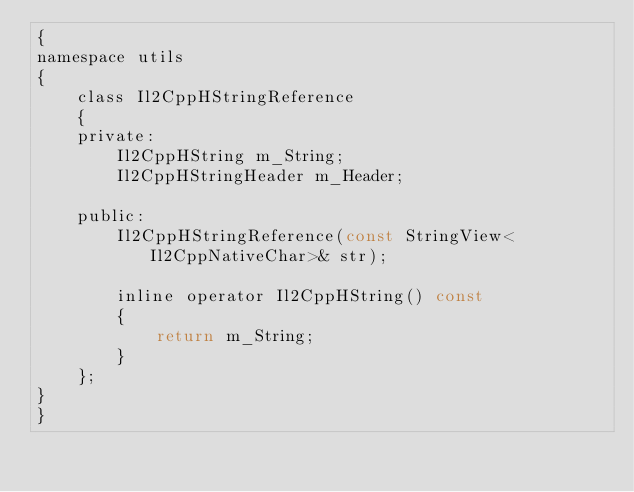Convert code to text. <code><loc_0><loc_0><loc_500><loc_500><_C_>{
namespace utils
{
    class Il2CppHStringReference
    {
    private:
        Il2CppHString m_String;
        Il2CppHStringHeader m_Header;

    public:
        Il2CppHStringReference(const StringView<Il2CppNativeChar>& str);

        inline operator Il2CppHString() const
        {
            return m_String;
        }
    };
}
}
</code> 